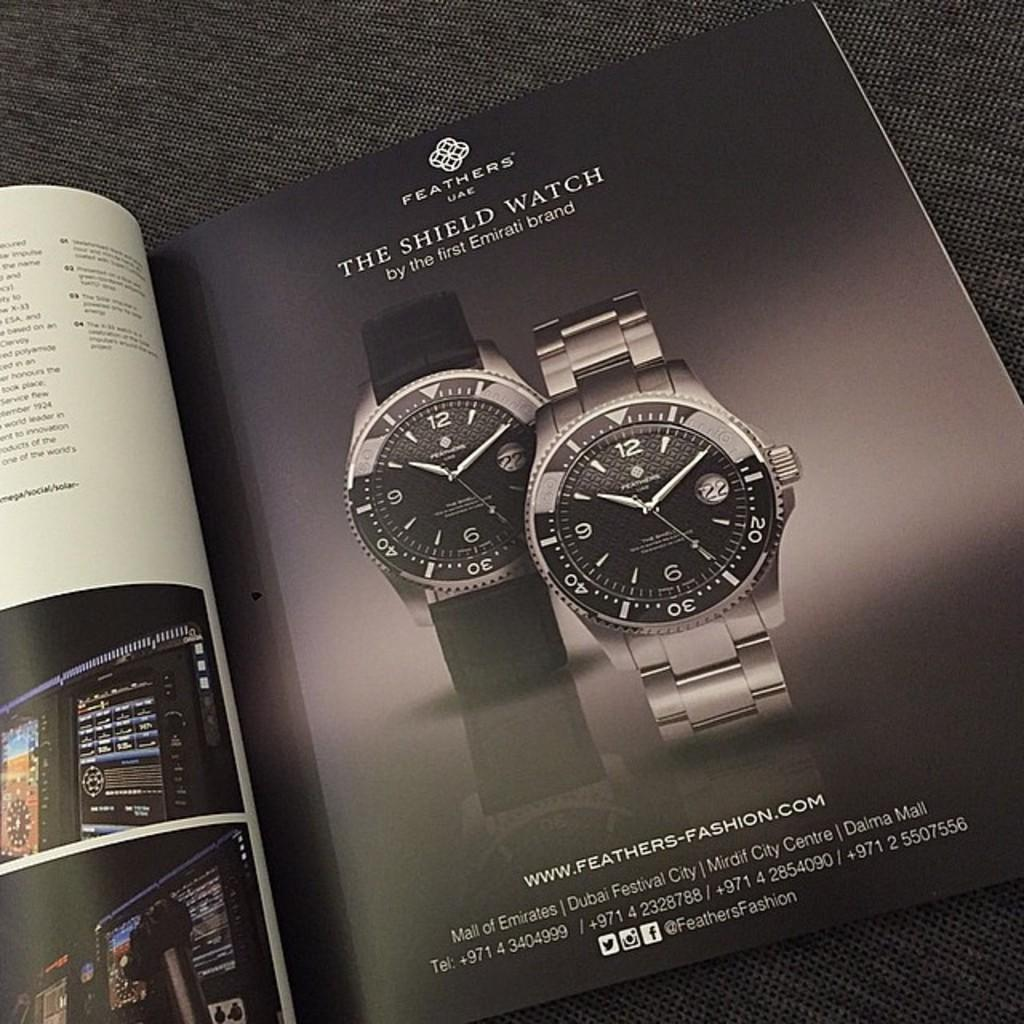Provide a one-sentence caption for the provided image. An ad in the magazine is for Feathers shield watches. 